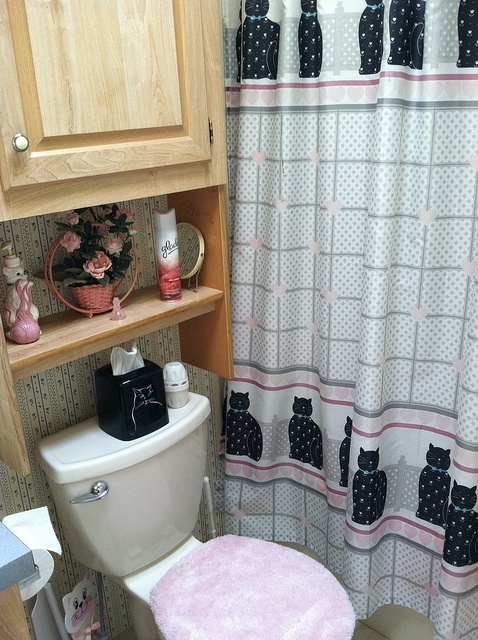Describe the objects in this image and their specific colors. I can see toilet in tan, lavender, darkgray, gray, and black tones, cat in tan, black, gray, darkgray, and darkblue tones, cat in tan, black, gray, and darkgray tones, cat in tan, black, gray, and darkgray tones, and cat in tan, black, gray, purple, and darkgray tones in this image. 